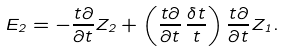<formula> <loc_0><loc_0><loc_500><loc_500>E _ { 2 } = - { \frac { t \partial } { \partial t } } Z _ { 2 } + \left ( { \frac { t \partial } { \partial t } } \, { \frac { \delta t } { t } } \right ) { \frac { t \partial } { \partial t } } Z _ { 1 } .</formula> 